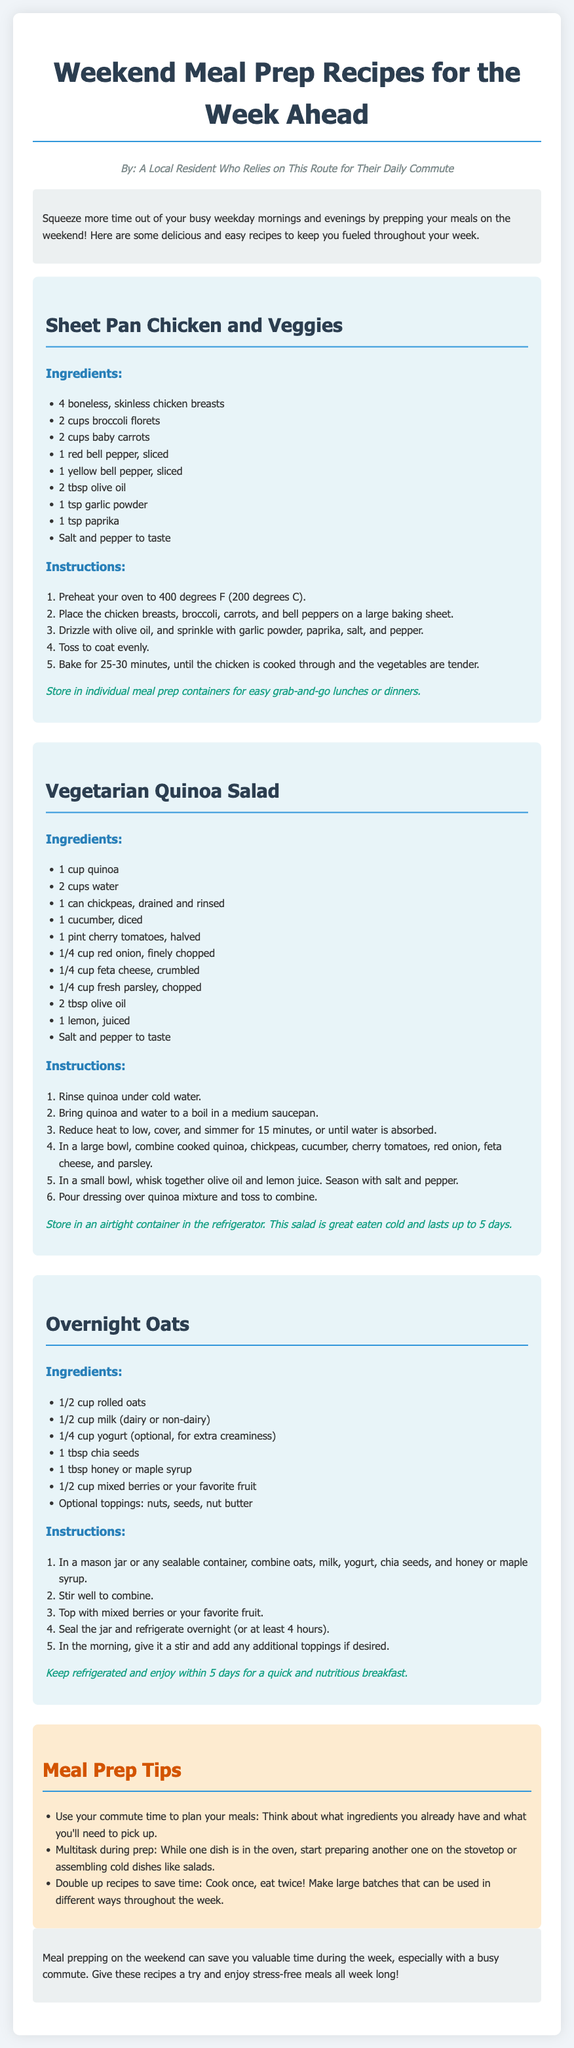What is the title of the document? The title is prominently displayed at the top of the document, indicating the main topic.
Answer: Weekend Meal Prep Recipes for the Week Ahead How many recipes are included in the document? The document contains three distinct recipes listed in separate sections.
Answer: 3 What is the main ingredient of the Vegetarian Quinoa Salad? The primary ingredient listed at the beginning of the ingredient section is quinoa.
Answer: Quinoa What cooking method is used for the Sheet Pan Chicken and Veggies? The instructions detail the process of baking the ingredients in the oven.
Answer: Baking How long should Overnight Oats be refrigerated before eating? The instructions specify a minimum time for the oats to be refrigerated prior to consumption.
Answer: 4 hours What type of dish can be prepared with chickpeas? The recipe specifically mentions using chickpeas in the Vegetarian Quinoa Salad.
Answer: Vegetarian Quinoa Salad What is a suggested topping for the Overnight Oats? The ingredients include optional toppings, providing flexibility in personalizing the dish.
Answer: Nuts What is a tip for meal prepping on the weekend? The tips section provides practical advice to streamline the meal prepping process during the weekend.
Answer: Use your commute time to plan your meals How do you store the Sheet Pan Chicken and Veggies? The storage instruction recommends a method for easy access to meals throughout the week.
Answer: Individual meal prep containers 